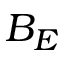<formula> <loc_0><loc_0><loc_500><loc_500>B _ { E }</formula> 